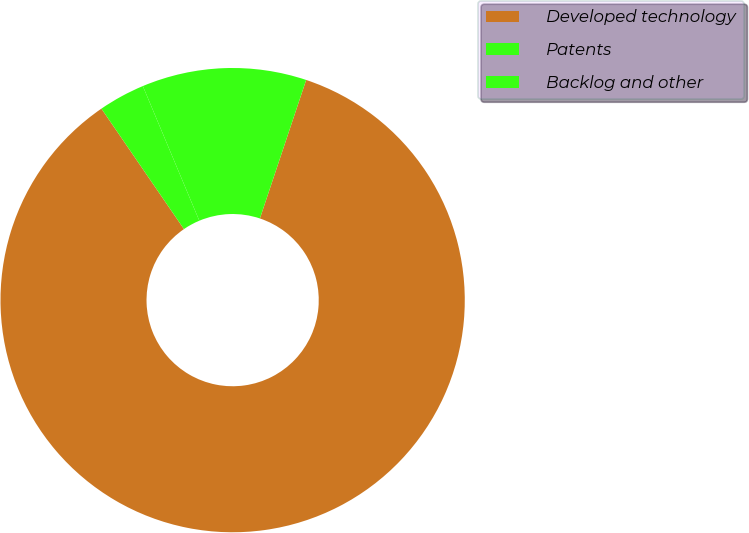<chart> <loc_0><loc_0><loc_500><loc_500><pie_chart><fcel>Developed technology<fcel>Patents<fcel>Backlog and other<nl><fcel>85.31%<fcel>11.45%<fcel>3.24%<nl></chart> 